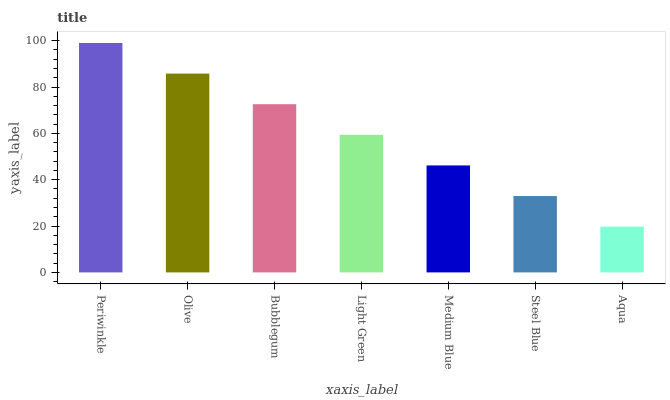Is Aqua the minimum?
Answer yes or no. Yes. Is Periwinkle the maximum?
Answer yes or no. Yes. Is Olive the minimum?
Answer yes or no. No. Is Olive the maximum?
Answer yes or no. No. Is Periwinkle greater than Olive?
Answer yes or no. Yes. Is Olive less than Periwinkle?
Answer yes or no. Yes. Is Olive greater than Periwinkle?
Answer yes or no. No. Is Periwinkle less than Olive?
Answer yes or no. No. Is Light Green the high median?
Answer yes or no. Yes. Is Light Green the low median?
Answer yes or no. Yes. Is Aqua the high median?
Answer yes or no. No. Is Bubblegum the low median?
Answer yes or no. No. 